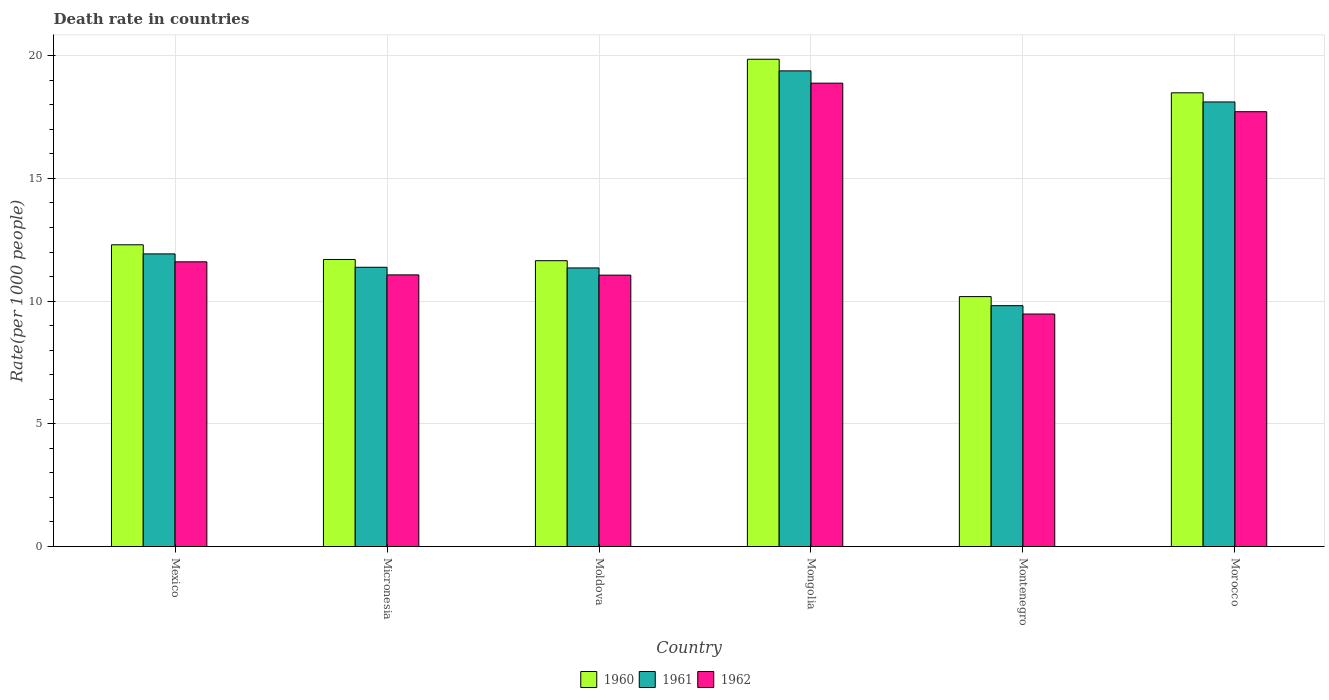How many different coloured bars are there?
Provide a short and direct response. 3. How many bars are there on the 3rd tick from the left?
Give a very brief answer. 3. What is the label of the 2nd group of bars from the left?
Offer a terse response. Micronesia. In how many cases, is the number of bars for a given country not equal to the number of legend labels?
Ensure brevity in your answer.  0. What is the death rate in 1961 in Morocco?
Offer a very short reply. 18.11. Across all countries, what is the maximum death rate in 1961?
Ensure brevity in your answer.  19.38. Across all countries, what is the minimum death rate in 1962?
Make the answer very short. 9.47. In which country was the death rate in 1960 maximum?
Offer a very short reply. Mongolia. In which country was the death rate in 1961 minimum?
Offer a terse response. Montenegro. What is the total death rate in 1960 in the graph?
Your answer should be very brief. 84.16. What is the difference between the death rate in 1962 in Mexico and that in Mongolia?
Make the answer very short. -7.28. What is the difference between the death rate in 1962 in Morocco and the death rate in 1961 in Mexico?
Ensure brevity in your answer.  5.79. What is the average death rate in 1962 per country?
Provide a short and direct response. 13.3. What is the difference between the death rate of/in 1960 and death rate of/in 1961 in Micronesia?
Your answer should be compact. 0.32. In how many countries, is the death rate in 1962 greater than 4?
Offer a terse response. 6. What is the ratio of the death rate in 1961 in Micronesia to that in Mongolia?
Your answer should be compact. 0.59. Is the difference between the death rate in 1960 in Mexico and Mongolia greater than the difference between the death rate in 1961 in Mexico and Mongolia?
Offer a very short reply. No. What is the difference between the highest and the second highest death rate in 1961?
Keep it short and to the point. -6.19. What is the difference between the highest and the lowest death rate in 1961?
Your answer should be compact. 9.57. What does the 2nd bar from the left in Micronesia represents?
Your answer should be compact. 1961. What does the 1st bar from the right in Micronesia represents?
Give a very brief answer. 1962. How many countries are there in the graph?
Provide a short and direct response. 6. Are the values on the major ticks of Y-axis written in scientific E-notation?
Ensure brevity in your answer.  No. Does the graph contain any zero values?
Your answer should be very brief. No. Does the graph contain grids?
Keep it short and to the point. Yes. How many legend labels are there?
Offer a terse response. 3. What is the title of the graph?
Give a very brief answer. Death rate in countries. Does "1975" appear as one of the legend labels in the graph?
Provide a short and direct response. No. What is the label or title of the Y-axis?
Provide a succinct answer. Rate(per 1000 people). What is the Rate(per 1000 people) of 1960 in Mexico?
Give a very brief answer. 12.29. What is the Rate(per 1000 people) in 1961 in Mexico?
Your response must be concise. 11.92. What is the Rate(per 1000 people) in 1960 in Micronesia?
Give a very brief answer. 11.7. What is the Rate(per 1000 people) in 1961 in Micronesia?
Provide a short and direct response. 11.38. What is the Rate(per 1000 people) in 1962 in Micronesia?
Your answer should be very brief. 11.07. What is the Rate(per 1000 people) of 1960 in Moldova?
Offer a terse response. 11.65. What is the Rate(per 1000 people) in 1961 in Moldova?
Your answer should be very brief. 11.35. What is the Rate(per 1000 people) of 1962 in Moldova?
Make the answer very short. 11.06. What is the Rate(per 1000 people) of 1960 in Mongolia?
Provide a succinct answer. 19.86. What is the Rate(per 1000 people) of 1961 in Mongolia?
Provide a short and direct response. 19.38. What is the Rate(per 1000 people) of 1962 in Mongolia?
Keep it short and to the point. 18.88. What is the Rate(per 1000 people) in 1960 in Montenegro?
Your answer should be very brief. 10.18. What is the Rate(per 1000 people) in 1961 in Montenegro?
Provide a succinct answer. 9.81. What is the Rate(per 1000 people) in 1962 in Montenegro?
Ensure brevity in your answer.  9.47. What is the Rate(per 1000 people) in 1960 in Morocco?
Offer a terse response. 18.49. What is the Rate(per 1000 people) in 1961 in Morocco?
Give a very brief answer. 18.11. What is the Rate(per 1000 people) of 1962 in Morocco?
Your answer should be compact. 17.72. Across all countries, what is the maximum Rate(per 1000 people) of 1960?
Ensure brevity in your answer.  19.86. Across all countries, what is the maximum Rate(per 1000 people) in 1961?
Provide a succinct answer. 19.38. Across all countries, what is the maximum Rate(per 1000 people) in 1962?
Offer a very short reply. 18.88. Across all countries, what is the minimum Rate(per 1000 people) in 1960?
Give a very brief answer. 10.18. Across all countries, what is the minimum Rate(per 1000 people) of 1961?
Offer a very short reply. 9.81. Across all countries, what is the minimum Rate(per 1000 people) of 1962?
Your response must be concise. 9.47. What is the total Rate(per 1000 people) in 1960 in the graph?
Ensure brevity in your answer.  84.16. What is the total Rate(per 1000 people) in 1961 in the graph?
Your answer should be compact. 81.96. What is the total Rate(per 1000 people) of 1962 in the graph?
Make the answer very short. 79.8. What is the difference between the Rate(per 1000 people) of 1960 in Mexico and that in Micronesia?
Provide a short and direct response. 0.6. What is the difference between the Rate(per 1000 people) in 1961 in Mexico and that in Micronesia?
Give a very brief answer. 0.55. What is the difference between the Rate(per 1000 people) of 1962 in Mexico and that in Micronesia?
Keep it short and to the point. 0.53. What is the difference between the Rate(per 1000 people) in 1960 in Mexico and that in Moldova?
Provide a succinct answer. 0.65. What is the difference between the Rate(per 1000 people) of 1961 in Mexico and that in Moldova?
Your answer should be compact. 0.57. What is the difference between the Rate(per 1000 people) of 1962 in Mexico and that in Moldova?
Provide a succinct answer. 0.54. What is the difference between the Rate(per 1000 people) in 1960 in Mexico and that in Mongolia?
Give a very brief answer. -7.56. What is the difference between the Rate(per 1000 people) of 1961 in Mexico and that in Mongolia?
Provide a succinct answer. -7.46. What is the difference between the Rate(per 1000 people) in 1962 in Mexico and that in Mongolia?
Offer a terse response. -7.28. What is the difference between the Rate(per 1000 people) of 1960 in Mexico and that in Montenegro?
Make the answer very short. 2.11. What is the difference between the Rate(per 1000 people) in 1961 in Mexico and that in Montenegro?
Your answer should be compact. 2.11. What is the difference between the Rate(per 1000 people) in 1962 in Mexico and that in Montenegro?
Your answer should be compact. 2.13. What is the difference between the Rate(per 1000 people) in 1960 in Mexico and that in Morocco?
Provide a short and direct response. -6.19. What is the difference between the Rate(per 1000 people) of 1961 in Mexico and that in Morocco?
Offer a very short reply. -6.19. What is the difference between the Rate(per 1000 people) of 1962 in Mexico and that in Morocco?
Keep it short and to the point. -6.12. What is the difference between the Rate(per 1000 people) in 1960 in Micronesia and that in Moldova?
Give a very brief answer. 0.05. What is the difference between the Rate(per 1000 people) in 1961 in Micronesia and that in Moldova?
Your answer should be very brief. 0.03. What is the difference between the Rate(per 1000 people) in 1962 in Micronesia and that in Moldova?
Your answer should be very brief. 0.01. What is the difference between the Rate(per 1000 people) of 1960 in Micronesia and that in Mongolia?
Offer a very short reply. -8.16. What is the difference between the Rate(per 1000 people) of 1961 in Micronesia and that in Mongolia?
Your answer should be compact. -8. What is the difference between the Rate(per 1000 people) of 1962 in Micronesia and that in Mongolia?
Keep it short and to the point. -7.81. What is the difference between the Rate(per 1000 people) of 1960 in Micronesia and that in Montenegro?
Your response must be concise. 1.51. What is the difference between the Rate(per 1000 people) of 1961 in Micronesia and that in Montenegro?
Keep it short and to the point. 1.56. What is the difference between the Rate(per 1000 people) in 1962 in Micronesia and that in Montenegro?
Make the answer very short. 1.59. What is the difference between the Rate(per 1000 people) in 1960 in Micronesia and that in Morocco?
Ensure brevity in your answer.  -6.79. What is the difference between the Rate(per 1000 people) of 1961 in Micronesia and that in Morocco?
Your response must be concise. -6.74. What is the difference between the Rate(per 1000 people) in 1962 in Micronesia and that in Morocco?
Your response must be concise. -6.65. What is the difference between the Rate(per 1000 people) in 1960 in Moldova and that in Mongolia?
Keep it short and to the point. -8.21. What is the difference between the Rate(per 1000 people) of 1961 in Moldova and that in Mongolia?
Make the answer very short. -8.03. What is the difference between the Rate(per 1000 people) in 1962 in Moldova and that in Mongolia?
Keep it short and to the point. -7.82. What is the difference between the Rate(per 1000 people) of 1960 in Moldova and that in Montenegro?
Your answer should be very brief. 1.46. What is the difference between the Rate(per 1000 people) in 1961 in Moldova and that in Montenegro?
Offer a very short reply. 1.54. What is the difference between the Rate(per 1000 people) in 1962 in Moldova and that in Montenegro?
Provide a short and direct response. 1.58. What is the difference between the Rate(per 1000 people) of 1960 in Moldova and that in Morocco?
Your answer should be compact. -6.84. What is the difference between the Rate(per 1000 people) in 1961 in Moldova and that in Morocco?
Offer a very short reply. -6.76. What is the difference between the Rate(per 1000 people) in 1962 in Moldova and that in Morocco?
Your response must be concise. -6.66. What is the difference between the Rate(per 1000 people) of 1960 in Mongolia and that in Montenegro?
Offer a terse response. 9.67. What is the difference between the Rate(per 1000 people) of 1961 in Mongolia and that in Montenegro?
Your answer should be very brief. 9.57. What is the difference between the Rate(per 1000 people) of 1962 in Mongolia and that in Montenegro?
Your answer should be very brief. 9.41. What is the difference between the Rate(per 1000 people) in 1960 in Mongolia and that in Morocco?
Provide a succinct answer. 1.37. What is the difference between the Rate(per 1000 people) of 1961 in Mongolia and that in Morocco?
Give a very brief answer. 1.27. What is the difference between the Rate(per 1000 people) in 1962 in Mongolia and that in Morocco?
Offer a terse response. 1.16. What is the difference between the Rate(per 1000 people) of 1960 in Montenegro and that in Morocco?
Keep it short and to the point. -8.3. What is the difference between the Rate(per 1000 people) of 1961 in Montenegro and that in Morocco?
Make the answer very short. -8.3. What is the difference between the Rate(per 1000 people) of 1962 in Montenegro and that in Morocco?
Provide a succinct answer. -8.24. What is the difference between the Rate(per 1000 people) of 1960 in Mexico and the Rate(per 1000 people) of 1961 in Micronesia?
Provide a succinct answer. 0.92. What is the difference between the Rate(per 1000 people) in 1960 in Mexico and the Rate(per 1000 people) in 1962 in Micronesia?
Offer a very short reply. 1.23. What is the difference between the Rate(per 1000 people) in 1961 in Mexico and the Rate(per 1000 people) in 1962 in Micronesia?
Your response must be concise. 0.85. What is the difference between the Rate(per 1000 people) of 1960 in Mexico and the Rate(per 1000 people) of 1961 in Moldova?
Give a very brief answer. 0.94. What is the difference between the Rate(per 1000 people) of 1960 in Mexico and the Rate(per 1000 people) of 1962 in Moldova?
Offer a very short reply. 1.24. What is the difference between the Rate(per 1000 people) of 1961 in Mexico and the Rate(per 1000 people) of 1962 in Moldova?
Keep it short and to the point. 0.86. What is the difference between the Rate(per 1000 people) of 1960 in Mexico and the Rate(per 1000 people) of 1961 in Mongolia?
Keep it short and to the point. -7.09. What is the difference between the Rate(per 1000 people) of 1960 in Mexico and the Rate(per 1000 people) of 1962 in Mongolia?
Keep it short and to the point. -6.59. What is the difference between the Rate(per 1000 people) in 1961 in Mexico and the Rate(per 1000 people) in 1962 in Mongolia?
Your answer should be compact. -6.96. What is the difference between the Rate(per 1000 people) of 1960 in Mexico and the Rate(per 1000 people) of 1961 in Montenegro?
Give a very brief answer. 2.48. What is the difference between the Rate(per 1000 people) in 1960 in Mexico and the Rate(per 1000 people) in 1962 in Montenegro?
Offer a very short reply. 2.82. What is the difference between the Rate(per 1000 people) in 1961 in Mexico and the Rate(per 1000 people) in 1962 in Montenegro?
Your answer should be very brief. 2.45. What is the difference between the Rate(per 1000 people) of 1960 in Mexico and the Rate(per 1000 people) of 1961 in Morocco?
Your answer should be compact. -5.82. What is the difference between the Rate(per 1000 people) in 1960 in Mexico and the Rate(per 1000 people) in 1962 in Morocco?
Provide a short and direct response. -5.42. What is the difference between the Rate(per 1000 people) of 1961 in Mexico and the Rate(per 1000 people) of 1962 in Morocco?
Offer a very short reply. -5.79. What is the difference between the Rate(per 1000 people) of 1960 in Micronesia and the Rate(per 1000 people) of 1961 in Moldova?
Ensure brevity in your answer.  0.34. What is the difference between the Rate(per 1000 people) of 1960 in Micronesia and the Rate(per 1000 people) of 1962 in Moldova?
Provide a succinct answer. 0.64. What is the difference between the Rate(per 1000 people) in 1961 in Micronesia and the Rate(per 1000 people) in 1962 in Moldova?
Give a very brief answer. 0.32. What is the difference between the Rate(per 1000 people) in 1960 in Micronesia and the Rate(per 1000 people) in 1961 in Mongolia?
Provide a short and direct response. -7.68. What is the difference between the Rate(per 1000 people) in 1960 in Micronesia and the Rate(per 1000 people) in 1962 in Mongolia?
Your answer should be compact. -7.18. What is the difference between the Rate(per 1000 people) in 1961 in Micronesia and the Rate(per 1000 people) in 1962 in Mongolia?
Keep it short and to the point. -7.5. What is the difference between the Rate(per 1000 people) in 1960 in Micronesia and the Rate(per 1000 people) in 1961 in Montenegro?
Ensure brevity in your answer.  1.88. What is the difference between the Rate(per 1000 people) of 1960 in Micronesia and the Rate(per 1000 people) of 1962 in Montenegro?
Offer a terse response. 2.22. What is the difference between the Rate(per 1000 people) of 1961 in Micronesia and the Rate(per 1000 people) of 1962 in Montenegro?
Give a very brief answer. 1.91. What is the difference between the Rate(per 1000 people) in 1960 in Micronesia and the Rate(per 1000 people) in 1961 in Morocco?
Offer a very short reply. -6.42. What is the difference between the Rate(per 1000 people) in 1960 in Micronesia and the Rate(per 1000 people) in 1962 in Morocco?
Offer a terse response. -6.02. What is the difference between the Rate(per 1000 people) of 1961 in Micronesia and the Rate(per 1000 people) of 1962 in Morocco?
Keep it short and to the point. -6.34. What is the difference between the Rate(per 1000 people) of 1960 in Moldova and the Rate(per 1000 people) of 1961 in Mongolia?
Your answer should be very brief. -7.74. What is the difference between the Rate(per 1000 people) of 1960 in Moldova and the Rate(per 1000 people) of 1962 in Mongolia?
Offer a very short reply. -7.23. What is the difference between the Rate(per 1000 people) in 1961 in Moldova and the Rate(per 1000 people) in 1962 in Mongolia?
Your answer should be compact. -7.53. What is the difference between the Rate(per 1000 people) of 1960 in Moldova and the Rate(per 1000 people) of 1961 in Montenegro?
Keep it short and to the point. 1.83. What is the difference between the Rate(per 1000 people) of 1960 in Moldova and the Rate(per 1000 people) of 1962 in Montenegro?
Your answer should be compact. 2.17. What is the difference between the Rate(per 1000 people) of 1961 in Moldova and the Rate(per 1000 people) of 1962 in Montenegro?
Your response must be concise. 1.88. What is the difference between the Rate(per 1000 people) of 1960 in Moldova and the Rate(per 1000 people) of 1961 in Morocco?
Your answer should be very brief. -6.47. What is the difference between the Rate(per 1000 people) in 1960 in Moldova and the Rate(per 1000 people) in 1962 in Morocco?
Ensure brevity in your answer.  -6.07. What is the difference between the Rate(per 1000 people) in 1961 in Moldova and the Rate(per 1000 people) in 1962 in Morocco?
Your answer should be compact. -6.37. What is the difference between the Rate(per 1000 people) in 1960 in Mongolia and the Rate(per 1000 people) in 1961 in Montenegro?
Your answer should be very brief. 10.04. What is the difference between the Rate(per 1000 people) of 1960 in Mongolia and the Rate(per 1000 people) of 1962 in Montenegro?
Provide a succinct answer. 10.38. What is the difference between the Rate(per 1000 people) of 1961 in Mongolia and the Rate(per 1000 people) of 1962 in Montenegro?
Provide a succinct answer. 9.91. What is the difference between the Rate(per 1000 people) of 1960 in Mongolia and the Rate(per 1000 people) of 1961 in Morocco?
Your answer should be very brief. 1.74. What is the difference between the Rate(per 1000 people) of 1960 in Mongolia and the Rate(per 1000 people) of 1962 in Morocco?
Your answer should be very brief. 2.14. What is the difference between the Rate(per 1000 people) in 1961 in Mongolia and the Rate(per 1000 people) in 1962 in Morocco?
Offer a terse response. 1.66. What is the difference between the Rate(per 1000 people) of 1960 in Montenegro and the Rate(per 1000 people) of 1961 in Morocco?
Your answer should be compact. -7.93. What is the difference between the Rate(per 1000 people) of 1960 in Montenegro and the Rate(per 1000 people) of 1962 in Morocco?
Offer a very short reply. -7.53. What is the difference between the Rate(per 1000 people) in 1961 in Montenegro and the Rate(per 1000 people) in 1962 in Morocco?
Give a very brief answer. -7.9. What is the average Rate(per 1000 people) of 1960 per country?
Your answer should be very brief. 14.03. What is the average Rate(per 1000 people) of 1961 per country?
Your response must be concise. 13.66. What is the average Rate(per 1000 people) of 1962 per country?
Make the answer very short. 13.3. What is the difference between the Rate(per 1000 people) in 1960 and Rate(per 1000 people) in 1961 in Mexico?
Keep it short and to the point. 0.37. What is the difference between the Rate(per 1000 people) of 1960 and Rate(per 1000 people) of 1962 in Mexico?
Make the answer very short. 0.69. What is the difference between the Rate(per 1000 people) of 1961 and Rate(per 1000 people) of 1962 in Mexico?
Give a very brief answer. 0.32. What is the difference between the Rate(per 1000 people) in 1960 and Rate(per 1000 people) in 1961 in Micronesia?
Ensure brevity in your answer.  0.32. What is the difference between the Rate(per 1000 people) in 1960 and Rate(per 1000 people) in 1962 in Micronesia?
Keep it short and to the point. 0.63. What is the difference between the Rate(per 1000 people) of 1961 and Rate(per 1000 people) of 1962 in Micronesia?
Keep it short and to the point. 0.31. What is the difference between the Rate(per 1000 people) in 1960 and Rate(per 1000 people) in 1961 in Moldova?
Offer a very short reply. 0.29. What is the difference between the Rate(per 1000 people) of 1960 and Rate(per 1000 people) of 1962 in Moldova?
Provide a short and direct response. 0.59. What is the difference between the Rate(per 1000 people) of 1961 and Rate(per 1000 people) of 1962 in Moldova?
Your answer should be very brief. 0.29. What is the difference between the Rate(per 1000 people) of 1960 and Rate(per 1000 people) of 1961 in Mongolia?
Provide a short and direct response. 0.47. What is the difference between the Rate(per 1000 people) in 1961 and Rate(per 1000 people) in 1962 in Mongolia?
Your answer should be compact. 0.5. What is the difference between the Rate(per 1000 people) in 1960 and Rate(per 1000 people) in 1961 in Montenegro?
Your answer should be very brief. 0.37. What is the difference between the Rate(per 1000 people) in 1960 and Rate(per 1000 people) in 1962 in Montenegro?
Your response must be concise. 0.71. What is the difference between the Rate(per 1000 people) in 1961 and Rate(per 1000 people) in 1962 in Montenegro?
Ensure brevity in your answer.  0.34. What is the difference between the Rate(per 1000 people) of 1960 and Rate(per 1000 people) of 1961 in Morocco?
Keep it short and to the point. 0.37. What is the difference between the Rate(per 1000 people) in 1960 and Rate(per 1000 people) in 1962 in Morocco?
Offer a very short reply. 0.77. What is the difference between the Rate(per 1000 people) of 1961 and Rate(per 1000 people) of 1962 in Morocco?
Provide a succinct answer. 0.4. What is the ratio of the Rate(per 1000 people) in 1960 in Mexico to that in Micronesia?
Keep it short and to the point. 1.05. What is the ratio of the Rate(per 1000 people) of 1961 in Mexico to that in Micronesia?
Keep it short and to the point. 1.05. What is the ratio of the Rate(per 1000 people) of 1962 in Mexico to that in Micronesia?
Provide a short and direct response. 1.05. What is the ratio of the Rate(per 1000 people) in 1960 in Mexico to that in Moldova?
Provide a succinct answer. 1.06. What is the ratio of the Rate(per 1000 people) of 1961 in Mexico to that in Moldova?
Ensure brevity in your answer.  1.05. What is the ratio of the Rate(per 1000 people) of 1962 in Mexico to that in Moldova?
Offer a terse response. 1.05. What is the ratio of the Rate(per 1000 people) of 1960 in Mexico to that in Mongolia?
Ensure brevity in your answer.  0.62. What is the ratio of the Rate(per 1000 people) in 1961 in Mexico to that in Mongolia?
Your answer should be compact. 0.62. What is the ratio of the Rate(per 1000 people) in 1962 in Mexico to that in Mongolia?
Your response must be concise. 0.61. What is the ratio of the Rate(per 1000 people) of 1960 in Mexico to that in Montenegro?
Ensure brevity in your answer.  1.21. What is the ratio of the Rate(per 1000 people) in 1961 in Mexico to that in Montenegro?
Provide a short and direct response. 1.22. What is the ratio of the Rate(per 1000 people) of 1962 in Mexico to that in Montenegro?
Provide a short and direct response. 1.22. What is the ratio of the Rate(per 1000 people) in 1960 in Mexico to that in Morocco?
Make the answer very short. 0.67. What is the ratio of the Rate(per 1000 people) in 1961 in Mexico to that in Morocco?
Keep it short and to the point. 0.66. What is the ratio of the Rate(per 1000 people) of 1962 in Mexico to that in Morocco?
Keep it short and to the point. 0.65. What is the ratio of the Rate(per 1000 people) of 1961 in Micronesia to that in Moldova?
Your response must be concise. 1. What is the ratio of the Rate(per 1000 people) of 1960 in Micronesia to that in Mongolia?
Provide a short and direct response. 0.59. What is the ratio of the Rate(per 1000 people) of 1961 in Micronesia to that in Mongolia?
Your response must be concise. 0.59. What is the ratio of the Rate(per 1000 people) in 1962 in Micronesia to that in Mongolia?
Your answer should be very brief. 0.59. What is the ratio of the Rate(per 1000 people) of 1960 in Micronesia to that in Montenegro?
Your answer should be very brief. 1.15. What is the ratio of the Rate(per 1000 people) in 1961 in Micronesia to that in Montenegro?
Your answer should be compact. 1.16. What is the ratio of the Rate(per 1000 people) in 1962 in Micronesia to that in Montenegro?
Keep it short and to the point. 1.17. What is the ratio of the Rate(per 1000 people) of 1960 in Micronesia to that in Morocco?
Offer a very short reply. 0.63. What is the ratio of the Rate(per 1000 people) in 1961 in Micronesia to that in Morocco?
Keep it short and to the point. 0.63. What is the ratio of the Rate(per 1000 people) in 1962 in Micronesia to that in Morocco?
Offer a terse response. 0.62. What is the ratio of the Rate(per 1000 people) in 1960 in Moldova to that in Mongolia?
Provide a short and direct response. 0.59. What is the ratio of the Rate(per 1000 people) of 1961 in Moldova to that in Mongolia?
Offer a terse response. 0.59. What is the ratio of the Rate(per 1000 people) in 1962 in Moldova to that in Mongolia?
Your answer should be very brief. 0.59. What is the ratio of the Rate(per 1000 people) of 1960 in Moldova to that in Montenegro?
Your answer should be compact. 1.14. What is the ratio of the Rate(per 1000 people) in 1961 in Moldova to that in Montenegro?
Offer a terse response. 1.16. What is the ratio of the Rate(per 1000 people) in 1962 in Moldova to that in Montenegro?
Make the answer very short. 1.17. What is the ratio of the Rate(per 1000 people) in 1960 in Moldova to that in Morocco?
Keep it short and to the point. 0.63. What is the ratio of the Rate(per 1000 people) in 1961 in Moldova to that in Morocco?
Make the answer very short. 0.63. What is the ratio of the Rate(per 1000 people) of 1962 in Moldova to that in Morocco?
Offer a very short reply. 0.62. What is the ratio of the Rate(per 1000 people) of 1960 in Mongolia to that in Montenegro?
Your answer should be compact. 1.95. What is the ratio of the Rate(per 1000 people) in 1961 in Mongolia to that in Montenegro?
Make the answer very short. 1.98. What is the ratio of the Rate(per 1000 people) in 1962 in Mongolia to that in Montenegro?
Offer a very short reply. 1.99. What is the ratio of the Rate(per 1000 people) of 1960 in Mongolia to that in Morocco?
Offer a terse response. 1.07. What is the ratio of the Rate(per 1000 people) of 1961 in Mongolia to that in Morocco?
Provide a short and direct response. 1.07. What is the ratio of the Rate(per 1000 people) of 1962 in Mongolia to that in Morocco?
Your response must be concise. 1.07. What is the ratio of the Rate(per 1000 people) in 1960 in Montenegro to that in Morocco?
Make the answer very short. 0.55. What is the ratio of the Rate(per 1000 people) of 1961 in Montenegro to that in Morocco?
Offer a terse response. 0.54. What is the ratio of the Rate(per 1000 people) of 1962 in Montenegro to that in Morocco?
Offer a terse response. 0.53. What is the difference between the highest and the second highest Rate(per 1000 people) in 1960?
Your answer should be very brief. 1.37. What is the difference between the highest and the second highest Rate(per 1000 people) in 1961?
Offer a terse response. 1.27. What is the difference between the highest and the second highest Rate(per 1000 people) of 1962?
Your answer should be very brief. 1.16. What is the difference between the highest and the lowest Rate(per 1000 people) in 1960?
Offer a very short reply. 9.67. What is the difference between the highest and the lowest Rate(per 1000 people) of 1961?
Ensure brevity in your answer.  9.57. What is the difference between the highest and the lowest Rate(per 1000 people) of 1962?
Give a very brief answer. 9.41. 